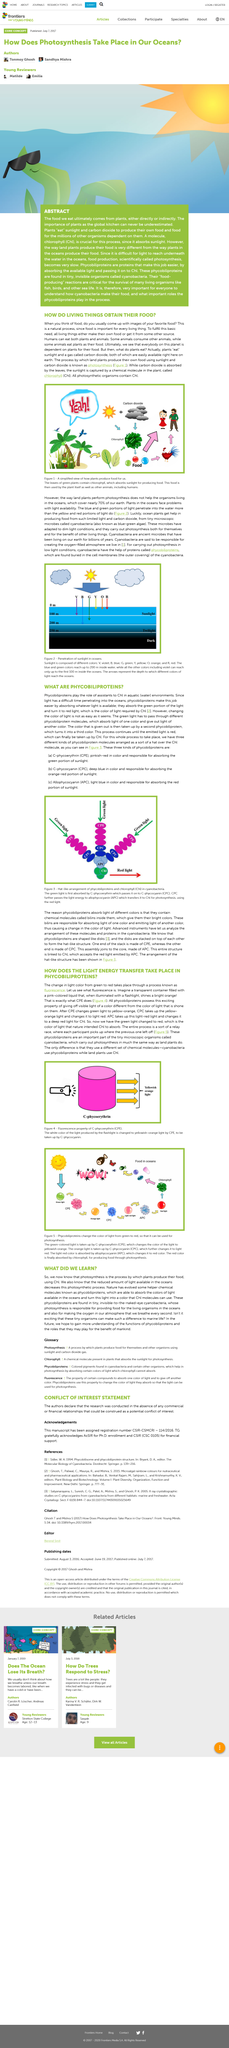Give some essential details in this illustration. Photosynthesis is the process by which plants produce food using sunlight and carbon dioxide. Plants use the process of photosynthesis to produce their own food, a process in which they convert sunlight, carbon dioxide, and water into glucose and oxygen. Living things, including humans, animals, and plants, are referred to in obtaining their food. 